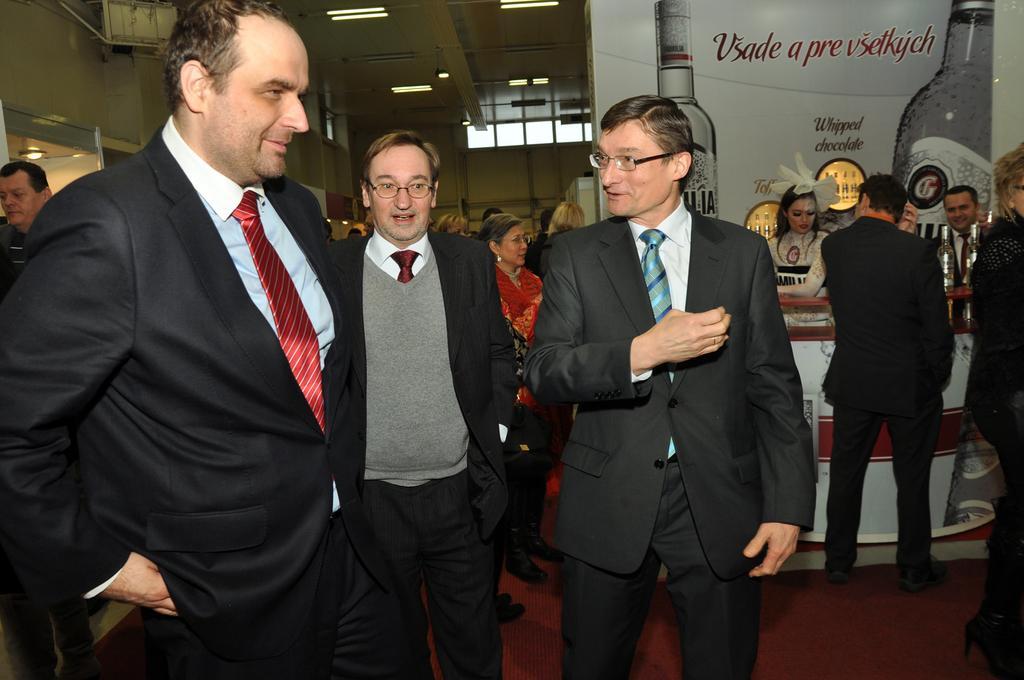In one or two sentences, can you explain what this image depicts? There are many people. Some are wearing specs. In the back there's a wall. On that there is a poster. On the poster there are bottles and something is written. In the back there's a wall. 